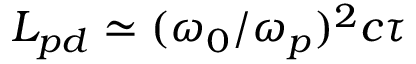Convert formula to latex. <formula><loc_0><loc_0><loc_500><loc_500>L _ { p d } \simeq ( { \omega _ { 0 } / \omega _ { p } } ) ^ { 2 } c \tau</formula> 